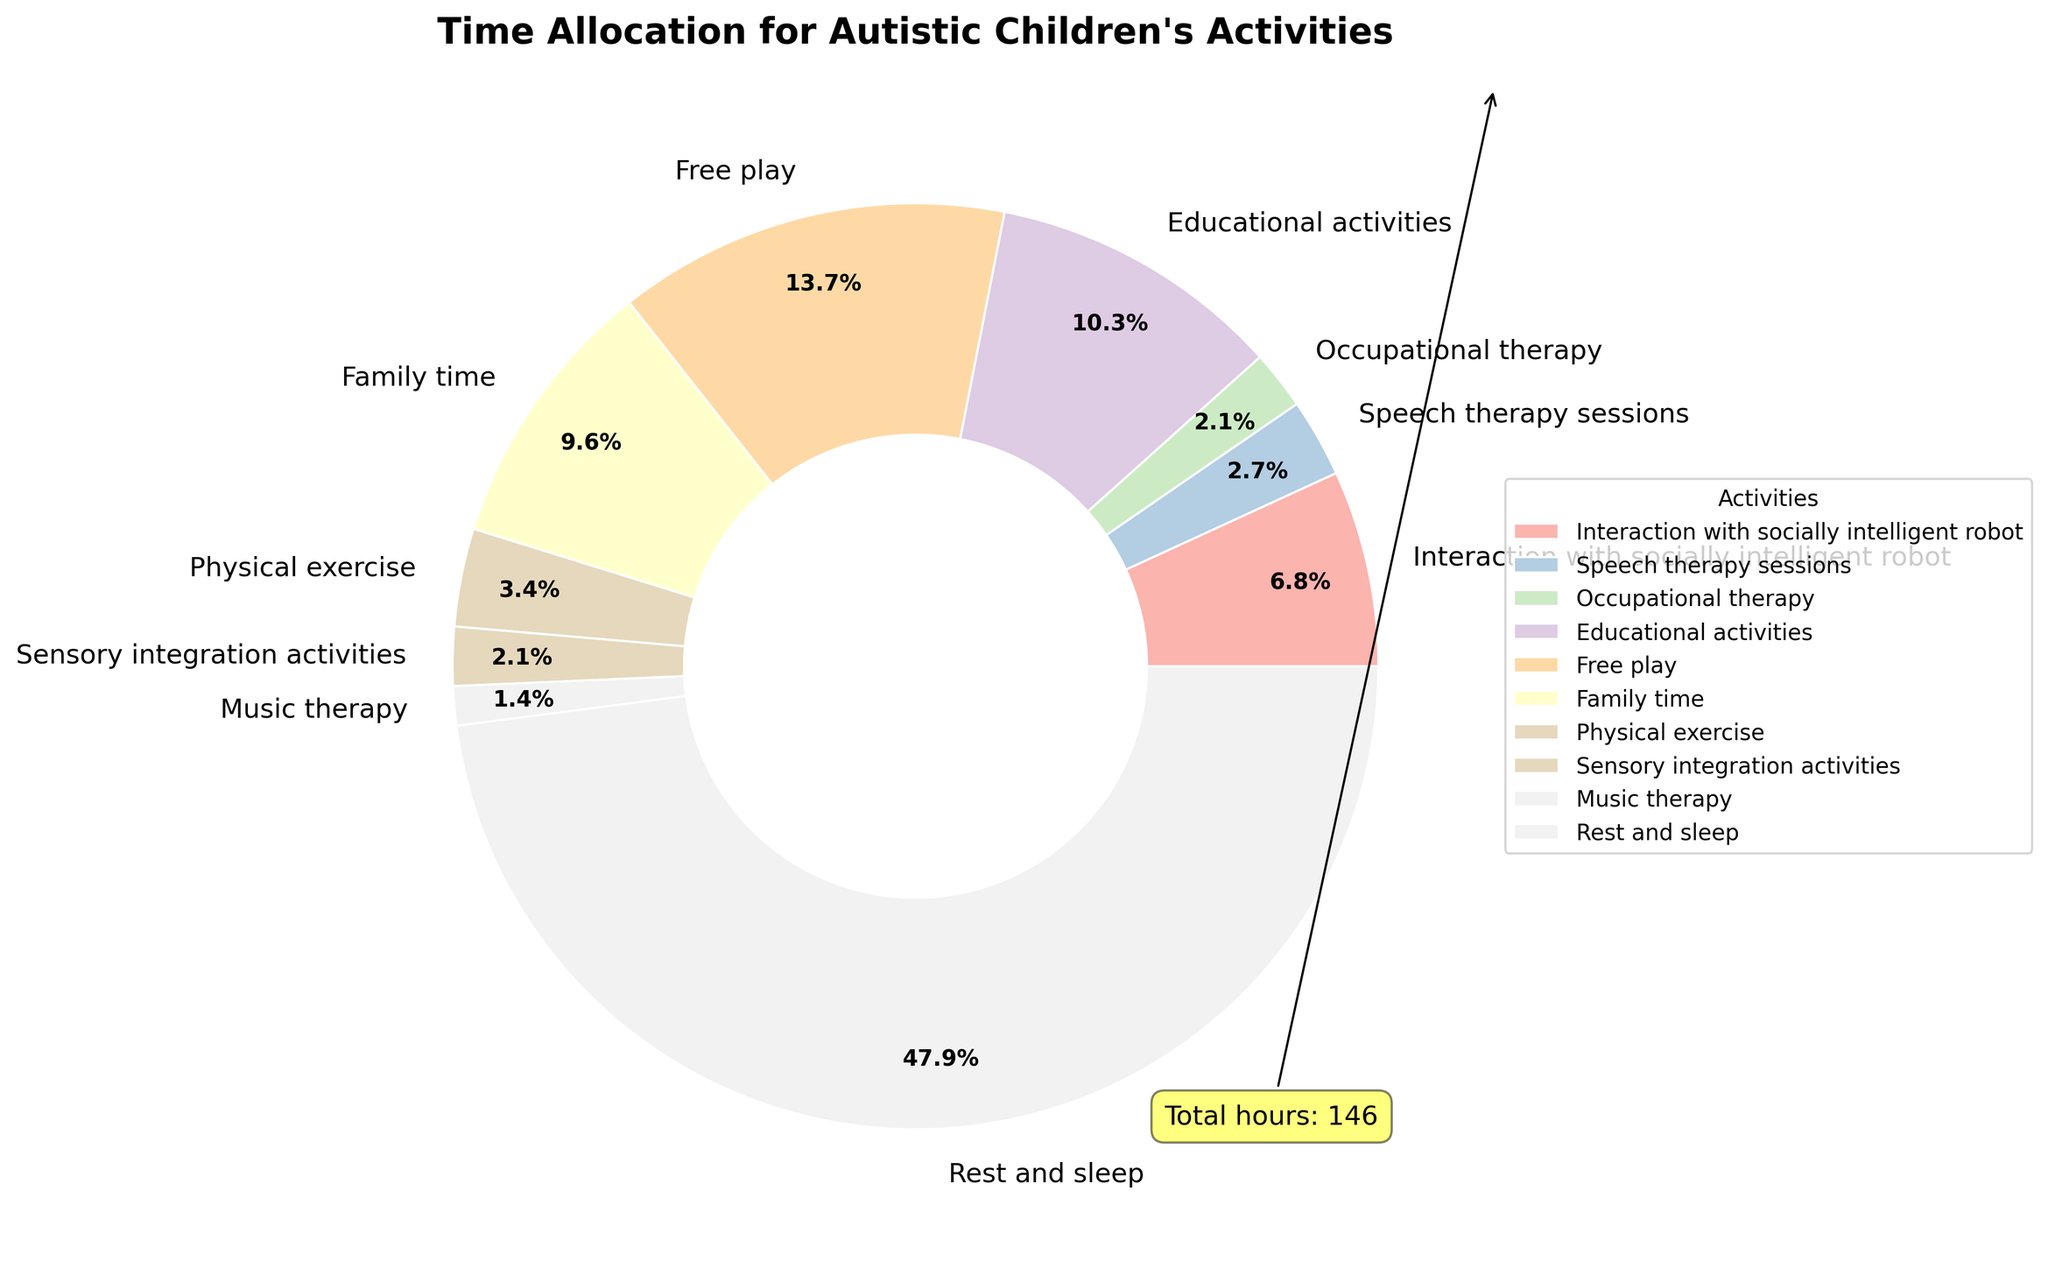What activity takes up the largest portion of the children's weekly hours? By visually inspecting the pie chart, we look for the largest segment.
Answer: Rest and sleep How many total hours do autistic children spend on therapy-related activities per week? Sum the hours from Speech therapy sessions (4), Occupational therapy (3), Sensory integration activities (3), and Music therapy (2). So, 4 + 3 + 3 + 2 = 12.
Answer: 12 Which activity occupies more time: educational activities or family time? Compare the sizes of the segments for Educational activities (15 hours) and Family time (14 hours). 15 > 14.
Answer: Educational activities What's the combined percentage of time spent on physical exercise and free play? Find the percentage values for Physical exercise and Free play by looking at the chart, and add them. If the chart shows Physical exercise as 3.4% and Free play as 13.7%, then 3.4% + 13.7% = 17.1%.
Answer: 17.1% What is the visual difference between the segment for interaction with socially intelligent robots and speech therapy? Look at the size and wedge width of the segments. The segment for Interaction with socially intelligent robots (10 hours) is larger than that for Speech therapy (4 hours).
Answer: Interaction with socially intelligent robots is larger How much more time is spent on free play compared to occupational therapy? Subtract the hours of Occupational therapy (3) from Free play (20). 20 - 3 = 17.
Answer: 17 What activities represent roughly the same percentage of time allocation? Inspect the pie chart for segments of approximately equal size. For instance, Speech therapy sessions (4 hours) and Sensory integration activities (3 hours) might look similar.
Answer: Speech therapy sessions and Sensory integration activities Which activities combined take up more than half of the weekly hours? Look at the activities with the largest wedges and add their hours. Rest and sleep (70) + Free play (20) + Family time (14). 70 + 20 + 14 = 104. 104 hours out of 146 is more than half.
Answer: Rest and sleep, Free play, Family time Is more time spent on interaction with socially intelligent robots or on physical exercise? Compare the segments for Interaction with socially intelligent robots (10 hours) and Physical exercise (5 hours). 10 > 5.
Answer: Interaction with socially intelligent robots 